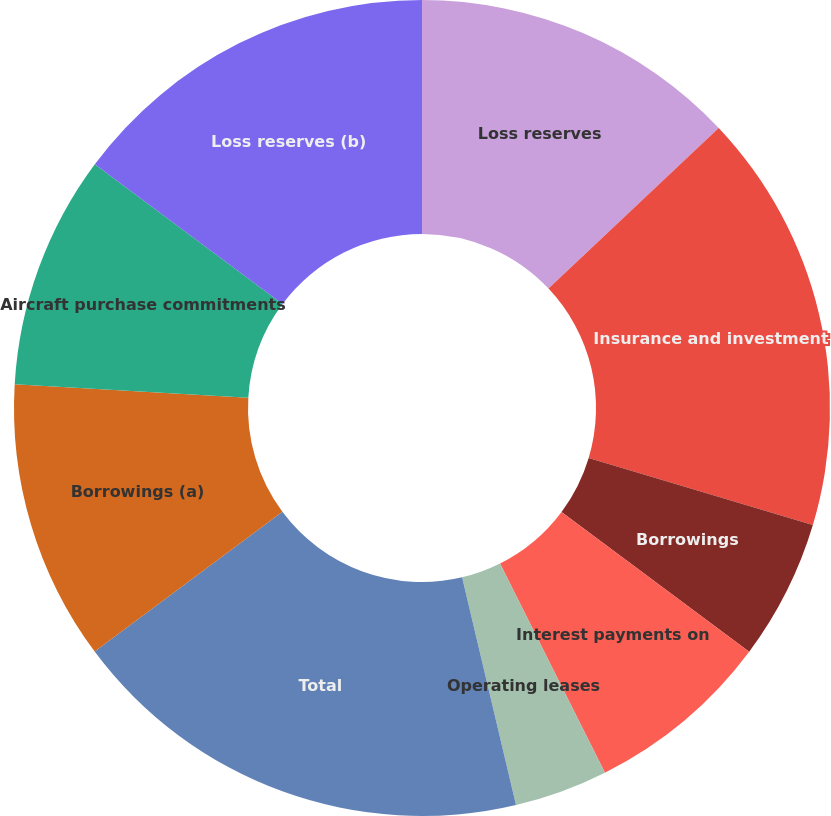<chart> <loc_0><loc_0><loc_500><loc_500><pie_chart><fcel>Loss reserves<fcel>Insurance and investment<fcel>Borrowings<fcel>Interest payments on<fcel>Operating leases<fcel>Other long-term obligations<fcel>Total<fcel>Borrowings (a)<fcel>Aircraft purchase commitments<fcel>Loss reserves (b)<nl><fcel>12.96%<fcel>16.67%<fcel>5.56%<fcel>7.41%<fcel>3.7%<fcel>0.0%<fcel>18.52%<fcel>11.11%<fcel>9.26%<fcel>14.81%<nl></chart> 